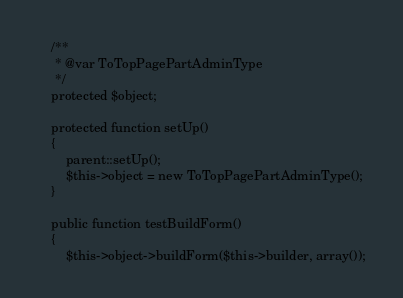<code> <loc_0><loc_0><loc_500><loc_500><_PHP_>    /**
     * @var ToTopPagePartAdminType
     */
    protected $object;

    protected function setUp()
    {
        parent::setUp();
        $this->object = new ToTopPagePartAdminType();
    }

    public function testBuildForm()
    {
        $this->object->buildForm($this->builder, array());</code> 